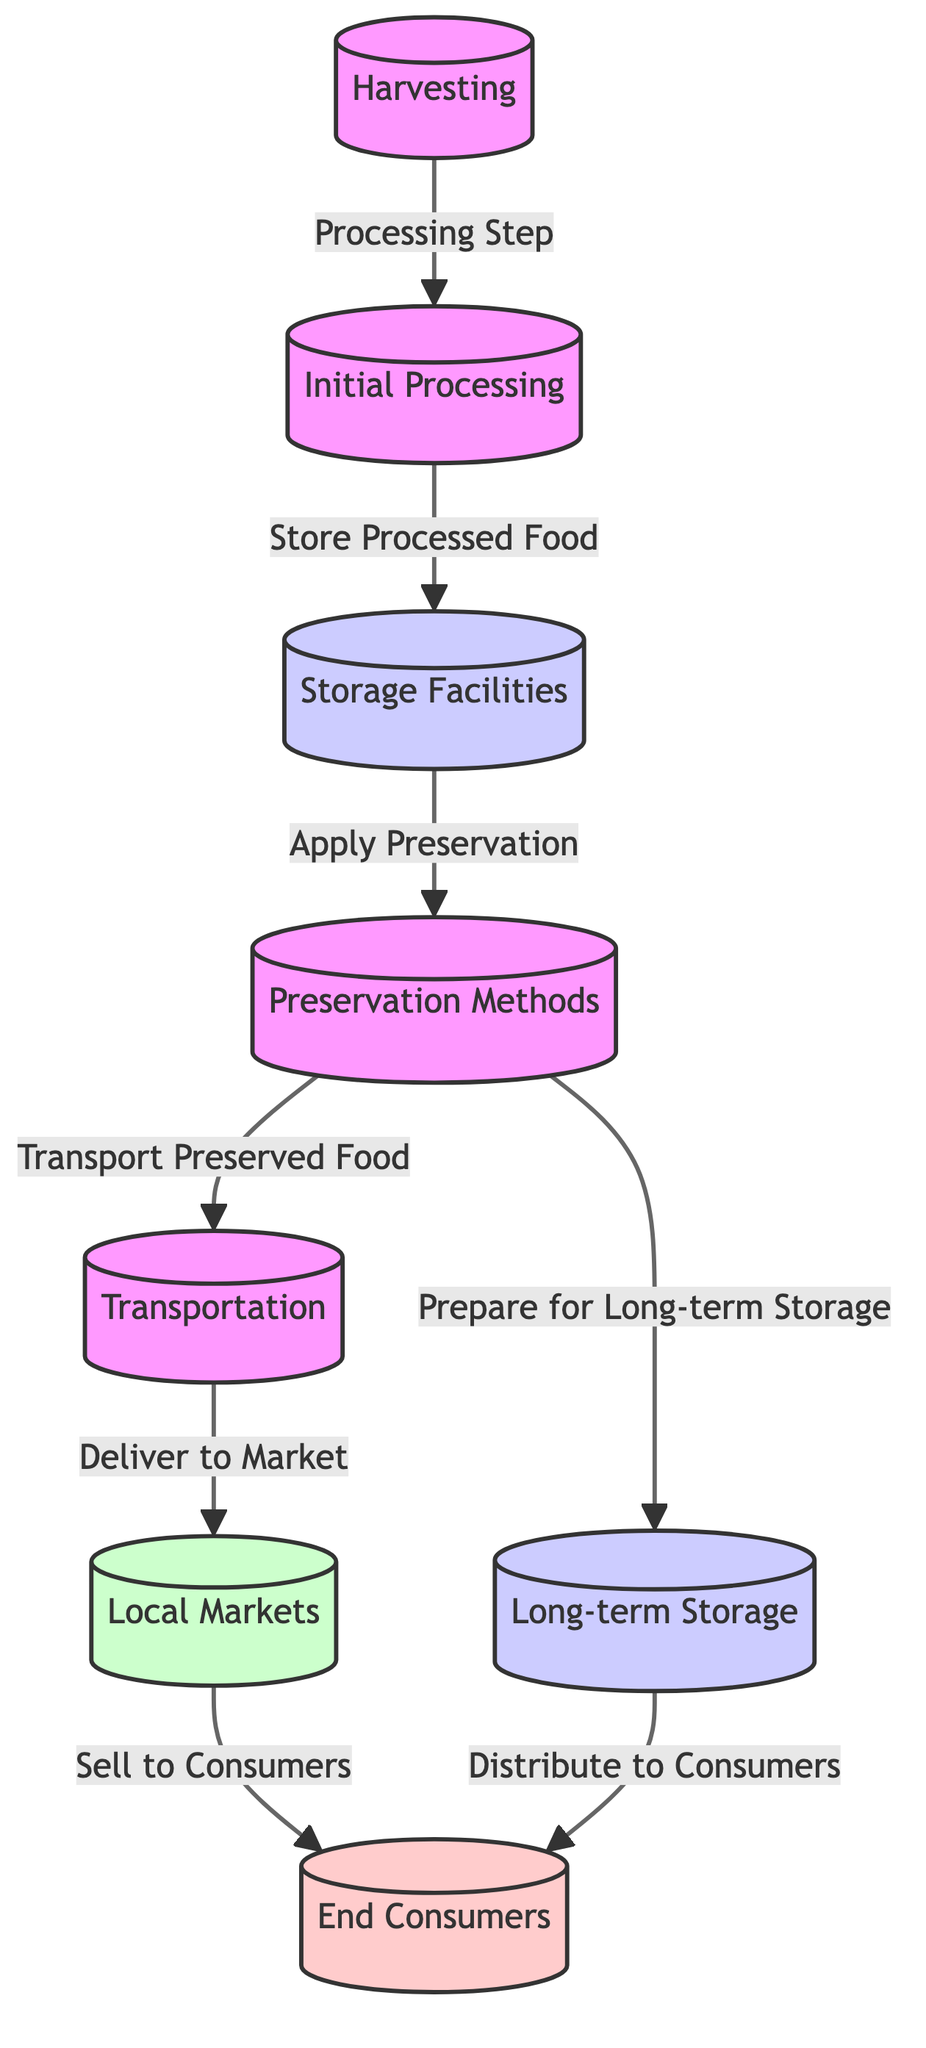What is the first step in the food preservation chain? The diagram indicates the first step is "Harvesting." This is the initial action that kick-starts the entire process of food preservation and storage.
Answer: Harvesting How many storage nodes are present in the diagram? There are two storage nodes indicated in the diagram: "Storage Facilities" and "Long-term Storage." These nodes represent different stages of storage within the supply chain.
Answer: 2 What is done after Initial Processing? After "Initial Processing," the next step, according to the diagram, is to "Store Processed Food." This reflects the sequence from processing to storage.
Answer: Store Processed Food Which node follows Preservation Methods? The node that follows "Preservation Methods" is "Transportation." The diagram demonstrates the flow from preservation to the next step of transporting the preserved food.
Answer: Transportation What is the relationship between Local Markets and End Consumers? The relationship is established through the action of "Sell to Consumers," which indicates that local markets facilitate the distribution of food to end consumers as part of the supply chain.
Answer: Sell to Consumers What is applied at the "Storage Facilities"? The diagram shows that "Apply Preservation" is the action that occurs at the "Storage Facilities." This signifies that preservation methods are employed immediately after food storage.
Answer: Apply Preservation What are the two final steps after Preservation Methods regarding distribution? The final steps are "Transport Preserved Food" and "Prepare for Long-term Storage," indicating that food may either be transported to local markets or set aside for long-term storage after being preserved.
Answer: Transport Preserved Food, Prepare for Long-term Storage How does food reach End Consumers after Preservation Methods? The food reaches End Consumers through two pathways: by being transported to Local Markets and sold, or by being distributed from Long-term Storage. This dual route showcases the complexity of food distribution in ancient supply chains.
Answer: Transported to Local Markets and distributed from Long-term Storage Which methods are used for preserving food before it is transported? The diagram specifies "Preservation Methods" as the techniques applied right after storage to ensure the food remains suitable for consumption before transportation.
Answer: Preservation Methods 